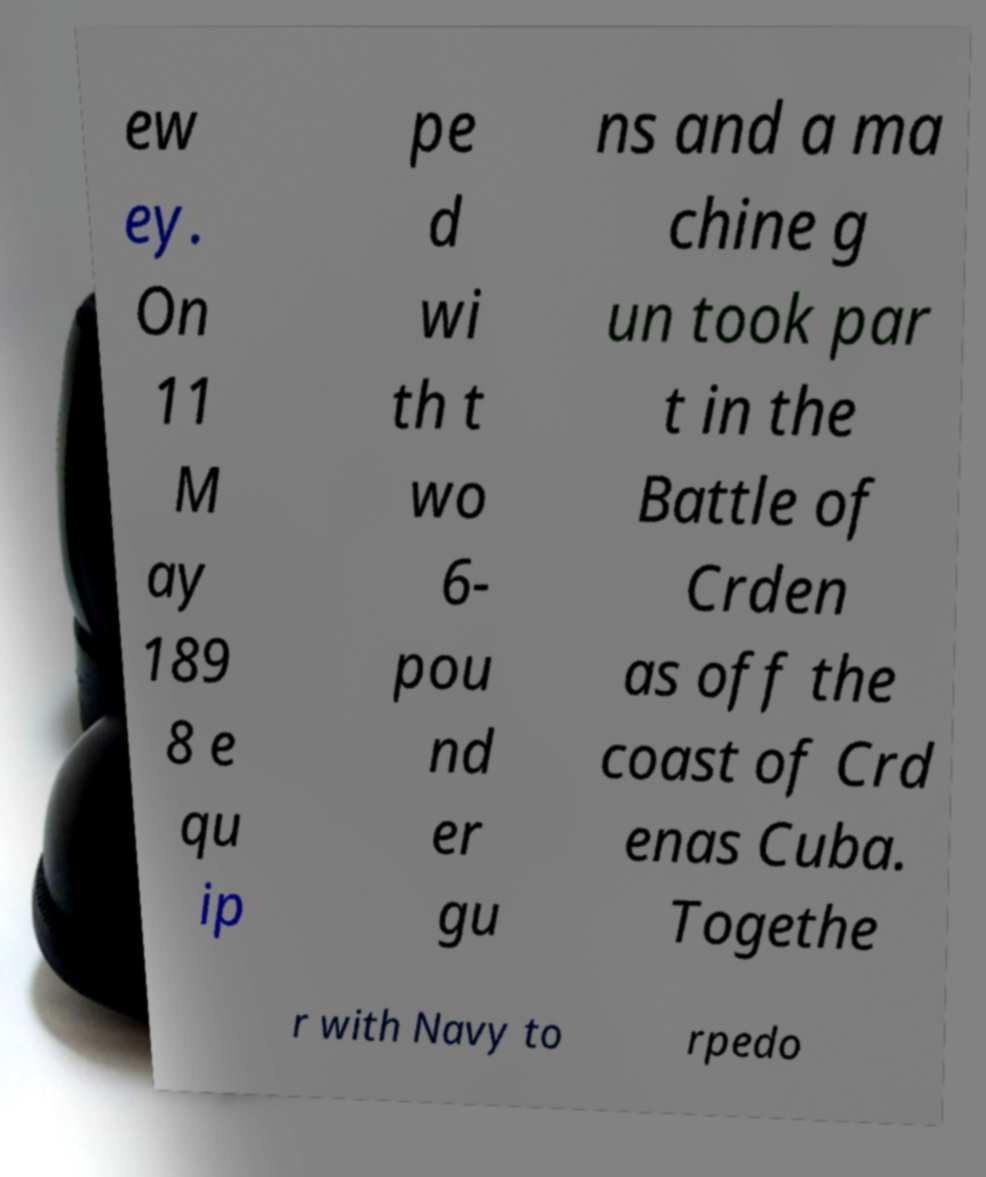What messages or text are displayed in this image? I need them in a readable, typed format. ew ey. On 11 M ay 189 8 e qu ip pe d wi th t wo 6- pou nd er gu ns and a ma chine g un took par t in the Battle of Crden as off the coast of Crd enas Cuba. Togethe r with Navy to rpedo 